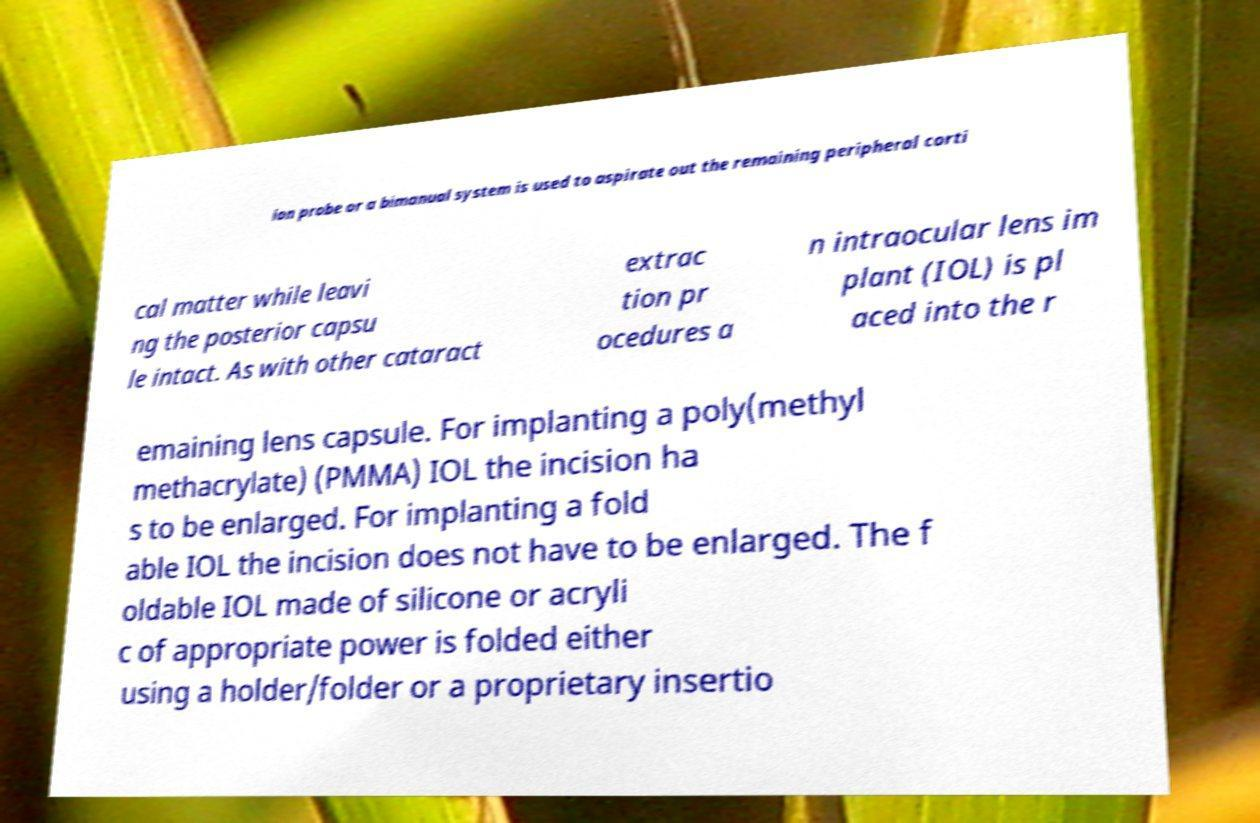Please identify and transcribe the text found in this image. ion probe or a bimanual system is used to aspirate out the remaining peripheral corti cal matter while leavi ng the posterior capsu le intact. As with other cataract extrac tion pr ocedures a n intraocular lens im plant (IOL) is pl aced into the r emaining lens capsule. For implanting a poly(methyl methacrylate) (PMMA) IOL the incision ha s to be enlarged. For implanting a fold able IOL the incision does not have to be enlarged. The f oldable IOL made of silicone or acryli c of appropriate power is folded either using a holder/folder or a proprietary insertio 